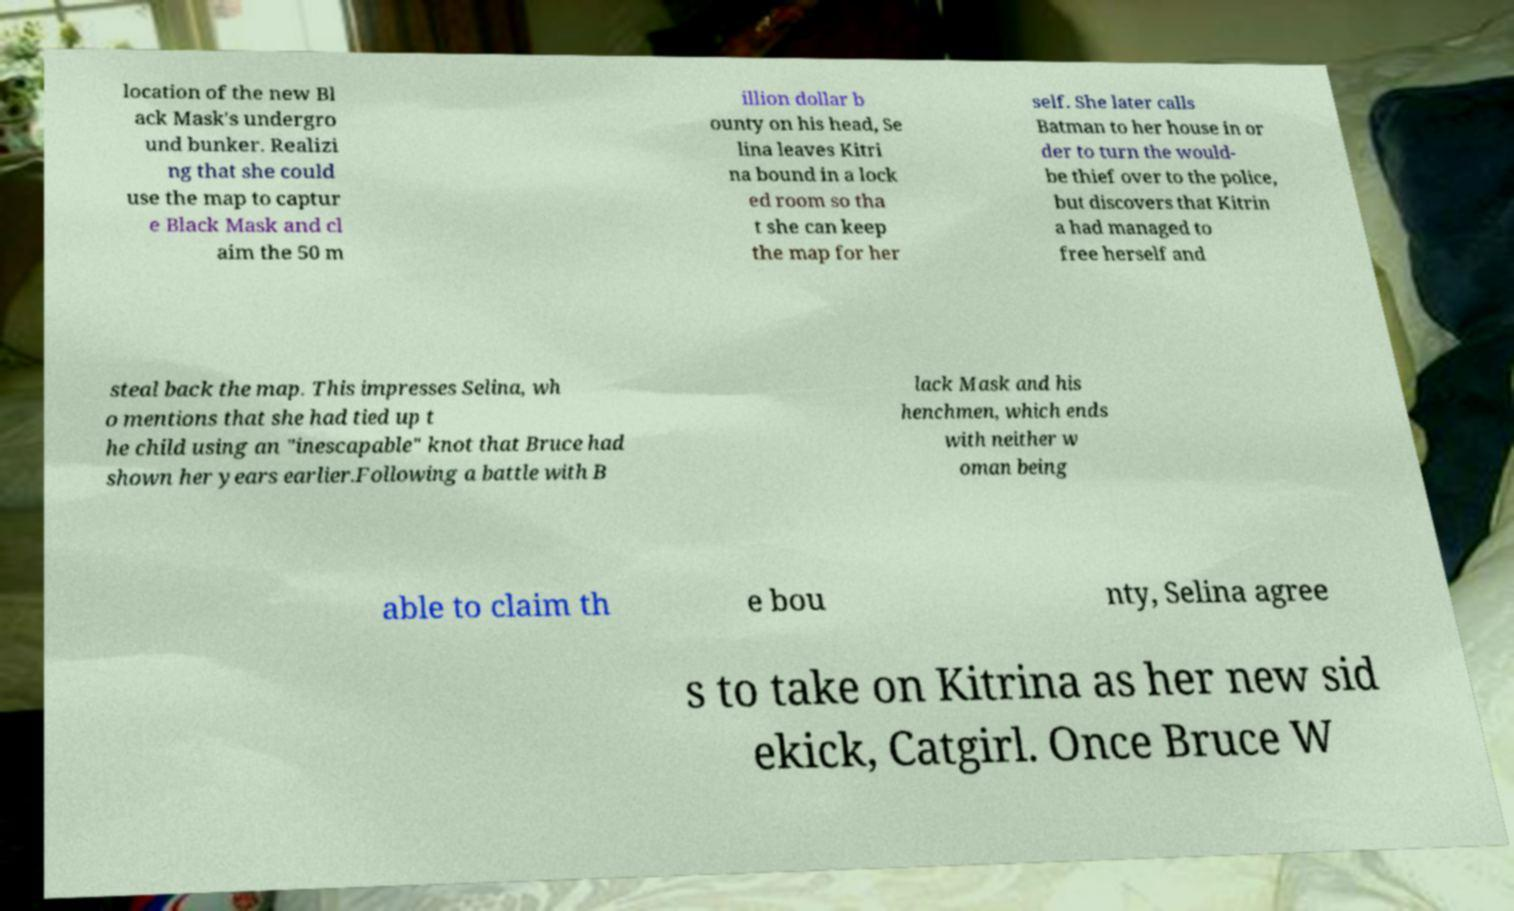Could you extract and type out the text from this image? location of the new Bl ack Mask's undergro und bunker. Realizi ng that she could use the map to captur e Black Mask and cl aim the 50 m illion dollar b ounty on his head, Se lina leaves Kitri na bound in a lock ed room so tha t she can keep the map for her self. She later calls Batman to her house in or der to turn the would- be thief over to the police, but discovers that Kitrin a had managed to free herself and steal back the map. This impresses Selina, wh o mentions that she had tied up t he child using an "inescapable" knot that Bruce had shown her years earlier.Following a battle with B lack Mask and his henchmen, which ends with neither w oman being able to claim th e bou nty, Selina agree s to take on Kitrina as her new sid ekick, Catgirl. Once Bruce W 